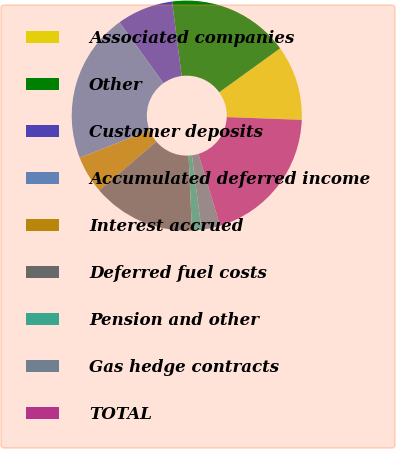Convert chart. <chart><loc_0><loc_0><loc_500><loc_500><pie_chart><fcel>Associated companies<fcel>Other<fcel>Customer deposits<fcel>Accumulated deferred income<fcel>Interest accrued<fcel>Deferred fuel costs<fcel>Pension and other<fcel>Gas hedge contracts<fcel>TOTAL<nl><fcel>10.53%<fcel>17.1%<fcel>7.9%<fcel>21.04%<fcel>5.27%<fcel>14.47%<fcel>1.33%<fcel>2.64%<fcel>19.73%<nl></chart> 